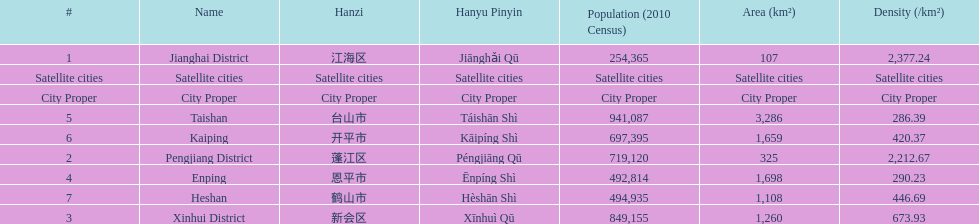What is the difference in population between enping and heshan? 2121. 